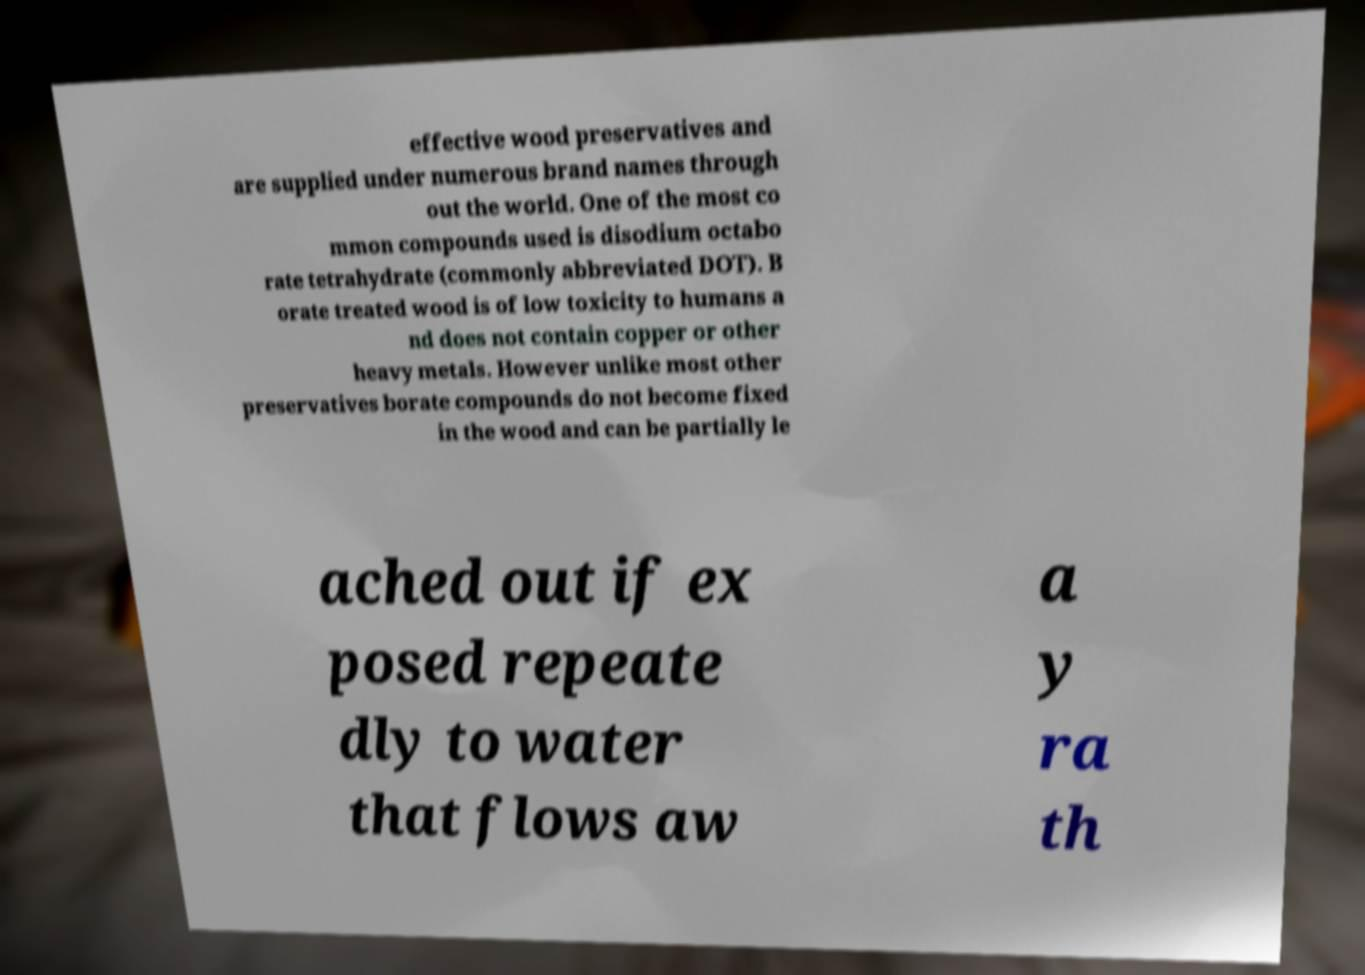There's text embedded in this image that I need extracted. Can you transcribe it verbatim? effective wood preservatives and are supplied under numerous brand names through out the world. One of the most co mmon compounds used is disodium octabo rate tetrahydrate (commonly abbreviated DOT). B orate treated wood is of low toxicity to humans a nd does not contain copper or other heavy metals. However unlike most other preservatives borate compounds do not become fixed in the wood and can be partially le ached out if ex posed repeate dly to water that flows aw a y ra th 